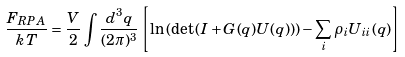<formula> <loc_0><loc_0><loc_500><loc_500>\frac { F _ { R P A } } { k T } = \frac { V } { 2 } \int \frac { d ^ { 3 } q } { ( 2 \pi ) ^ { 3 } } \left [ \ln \left ( \det \left ( { I } + { G } ( q ) { U } ( q ) \right ) \right ) - \sum _ { i } \rho _ { i } U _ { i i } ( q ) \right ]</formula> 